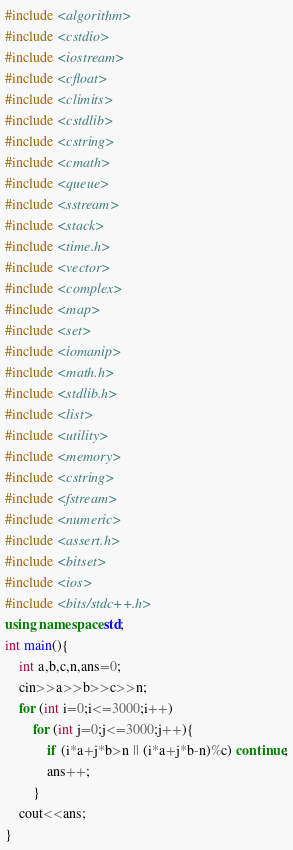Convert code to text. <code><loc_0><loc_0><loc_500><loc_500><_C++_>#include <algorithm>
#include <cstdio>
#include <iostream>
#include <cfloat>
#include <climits>
#include <cstdlib>
#include <cstring>
#include <cmath>
#include <queue>
#include <sstream>
#include <stack>
#include <time.h>
#include <vector>
#include <complex>
#include <map>
#include <set>
#include <iomanip>
#include <math.h>
#include <stdlib.h>
#include <list>
#include <utility>
#include <memory>
#include <cstring>
#include <fstream>
#include <numeric>
#include <assert.h>
#include <bitset>
#include <ios> 
#include <bits/stdc++.h>
using namespace std;
int main(){
	int a,b,c,n,ans=0;
	cin>>a>>b>>c>>n;
	for (int i=0;i<=3000;i++)
		for (int j=0;j<=3000;j++){
			if (i*a+j*b>n || (i*a+j*b-n)%c) continue;
			ans++;
		}
	cout<<ans;
}</code> 